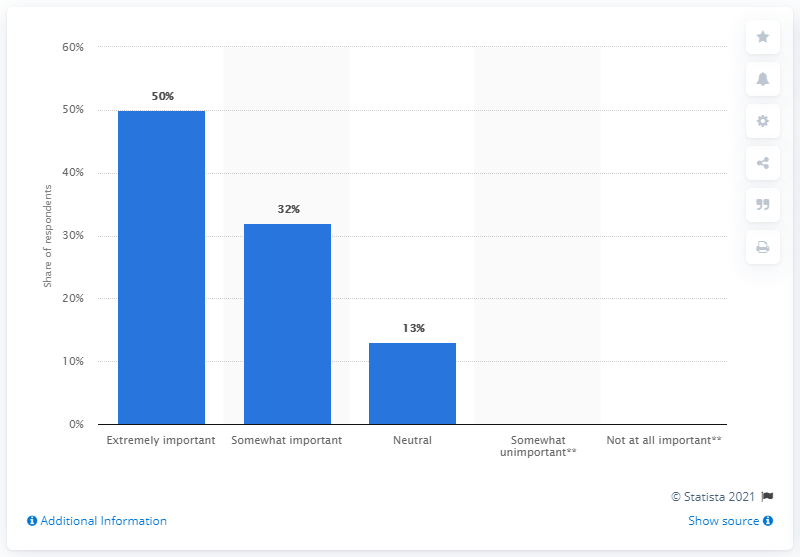Identify some key points in this picture. According to the data, 32% of respondents rated style, fashion, and fit as somewhat important. 